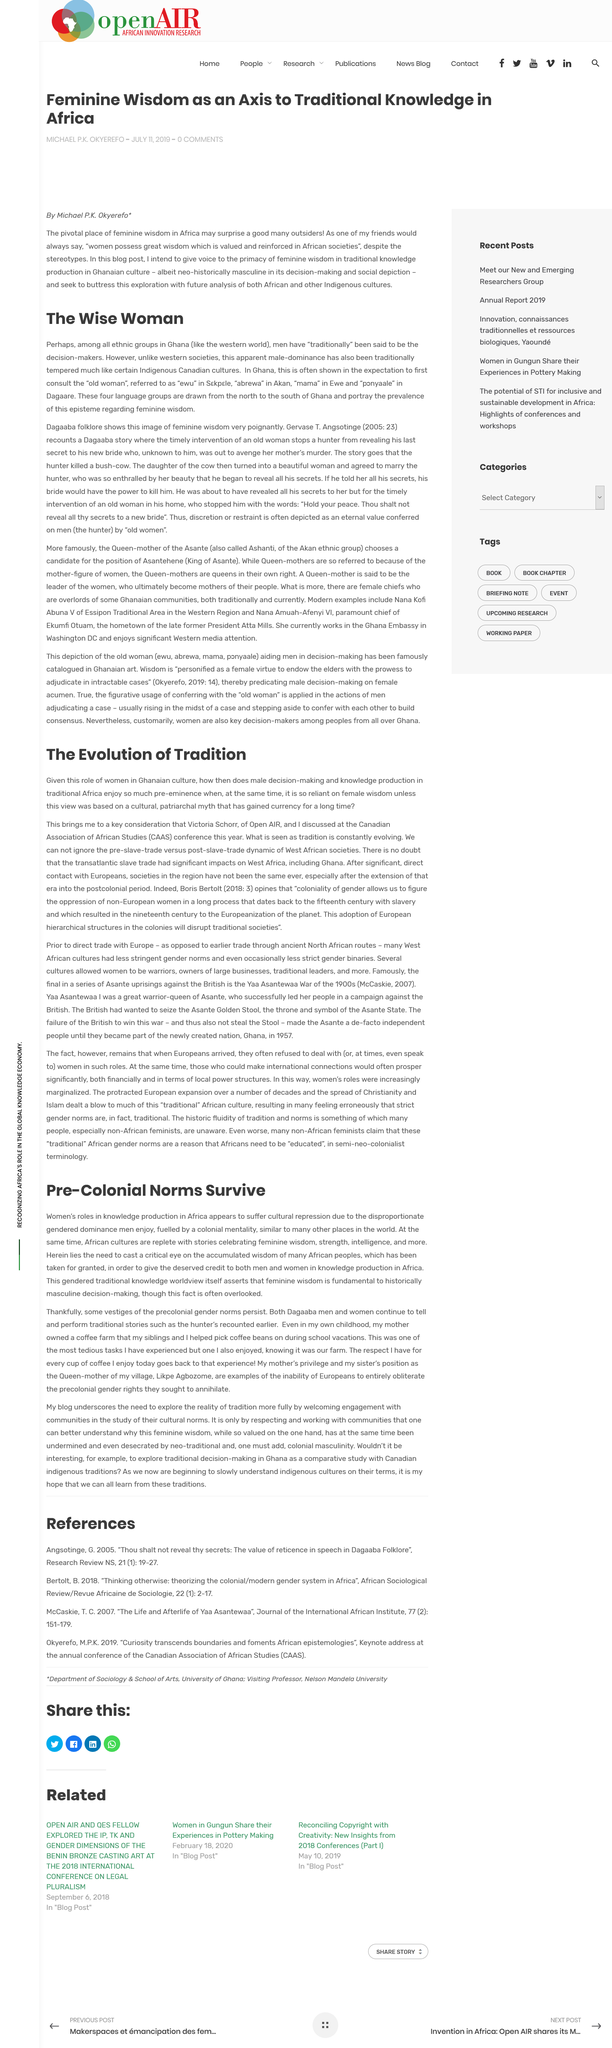Outline some significant characteristics in this image. The continent referred to in the text is Africa. In Ghana, male dominance is tempered due to the expectation that the "old woman" is consulted prior to making decisions, reflecting the importance of female wisdom and input in cultural decision-making. Abrewa" is the word for "old woman" in the Akan language group of Ghana. The gender group that is described as more repressed in the text is women. African culture is rich with stories that highlight the feminine wisdom, strength, and intelligence of women. 